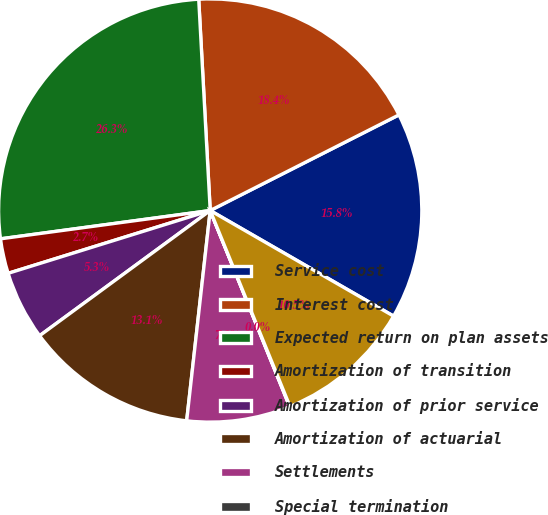<chart> <loc_0><loc_0><loc_500><loc_500><pie_chart><fcel>Service cost<fcel>Interest cost<fcel>Expected return on plan assets<fcel>Amortization of transition<fcel>Amortization of prior service<fcel>Amortization of actuarial<fcel>Settlements<fcel>Special termination<fcel>Net periodic (benefit) cost<nl><fcel>15.78%<fcel>18.4%<fcel>26.27%<fcel>2.66%<fcel>5.28%<fcel>13.15%<fcel>7.9%<fcel>0.03%<fcel>10.53%<nl></chart> 